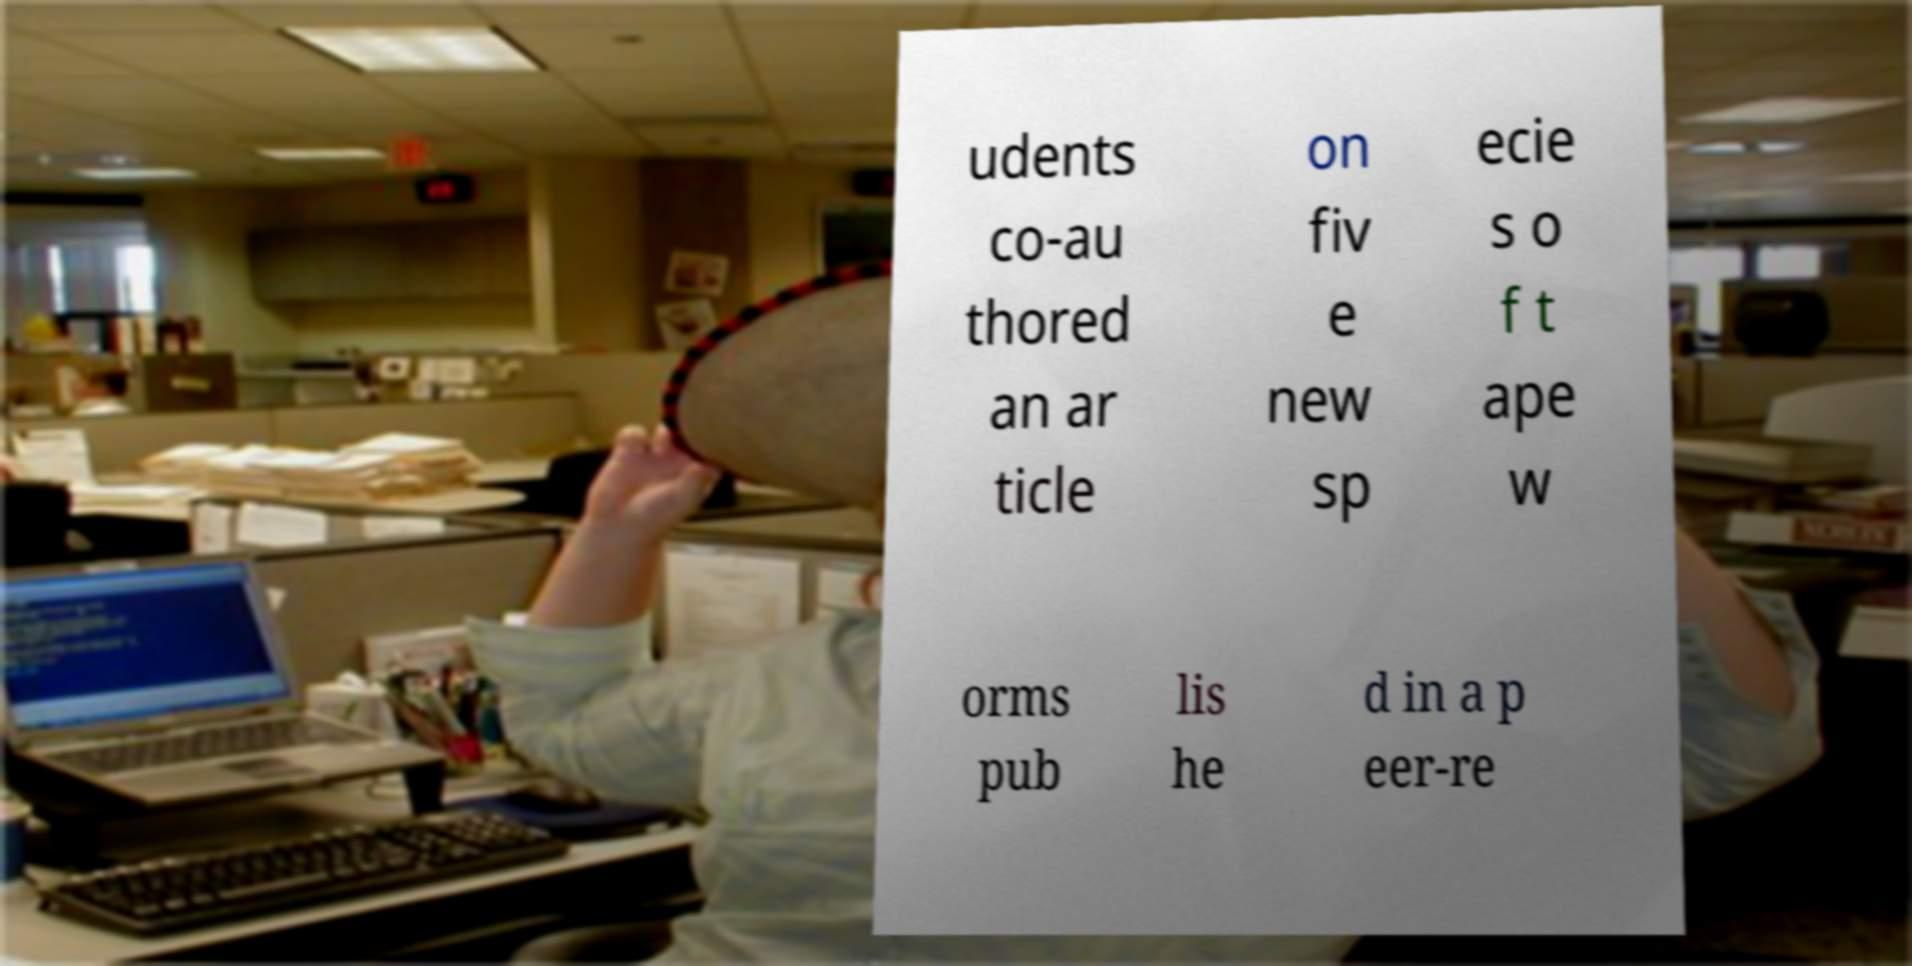For documentation purposes, I need the text within this image transcribed. Could you provide that? udents co-au thored an ar ticle on fiv e new sp ecie s o f t ape w orms pub lis he d in a p eer-re 